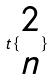<formula> <loc_0><loc_0><loc_500><loc_500>t \{ \begin{matrix} 2 \\ n \end{matrix} \}</formula> 